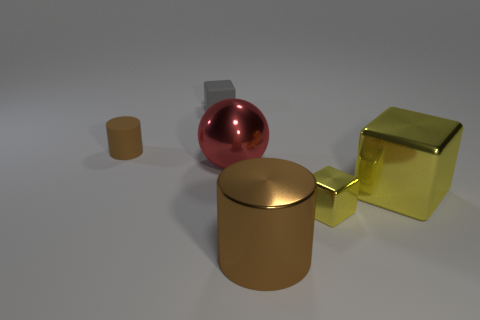Add 1 red cylinders. How many objects exist? 7 Subtract all balls. How many objects are left? 5 Add 6 large shiny objects. How many large shiny objects exist? 9 Subtract 1 gray blocks. How many objects are left? 5 Subtract all objects. Subtract all blue metal spheres. How many objects are left? 0 Add 4 gray blocks. How many gray blocks are left? 5 